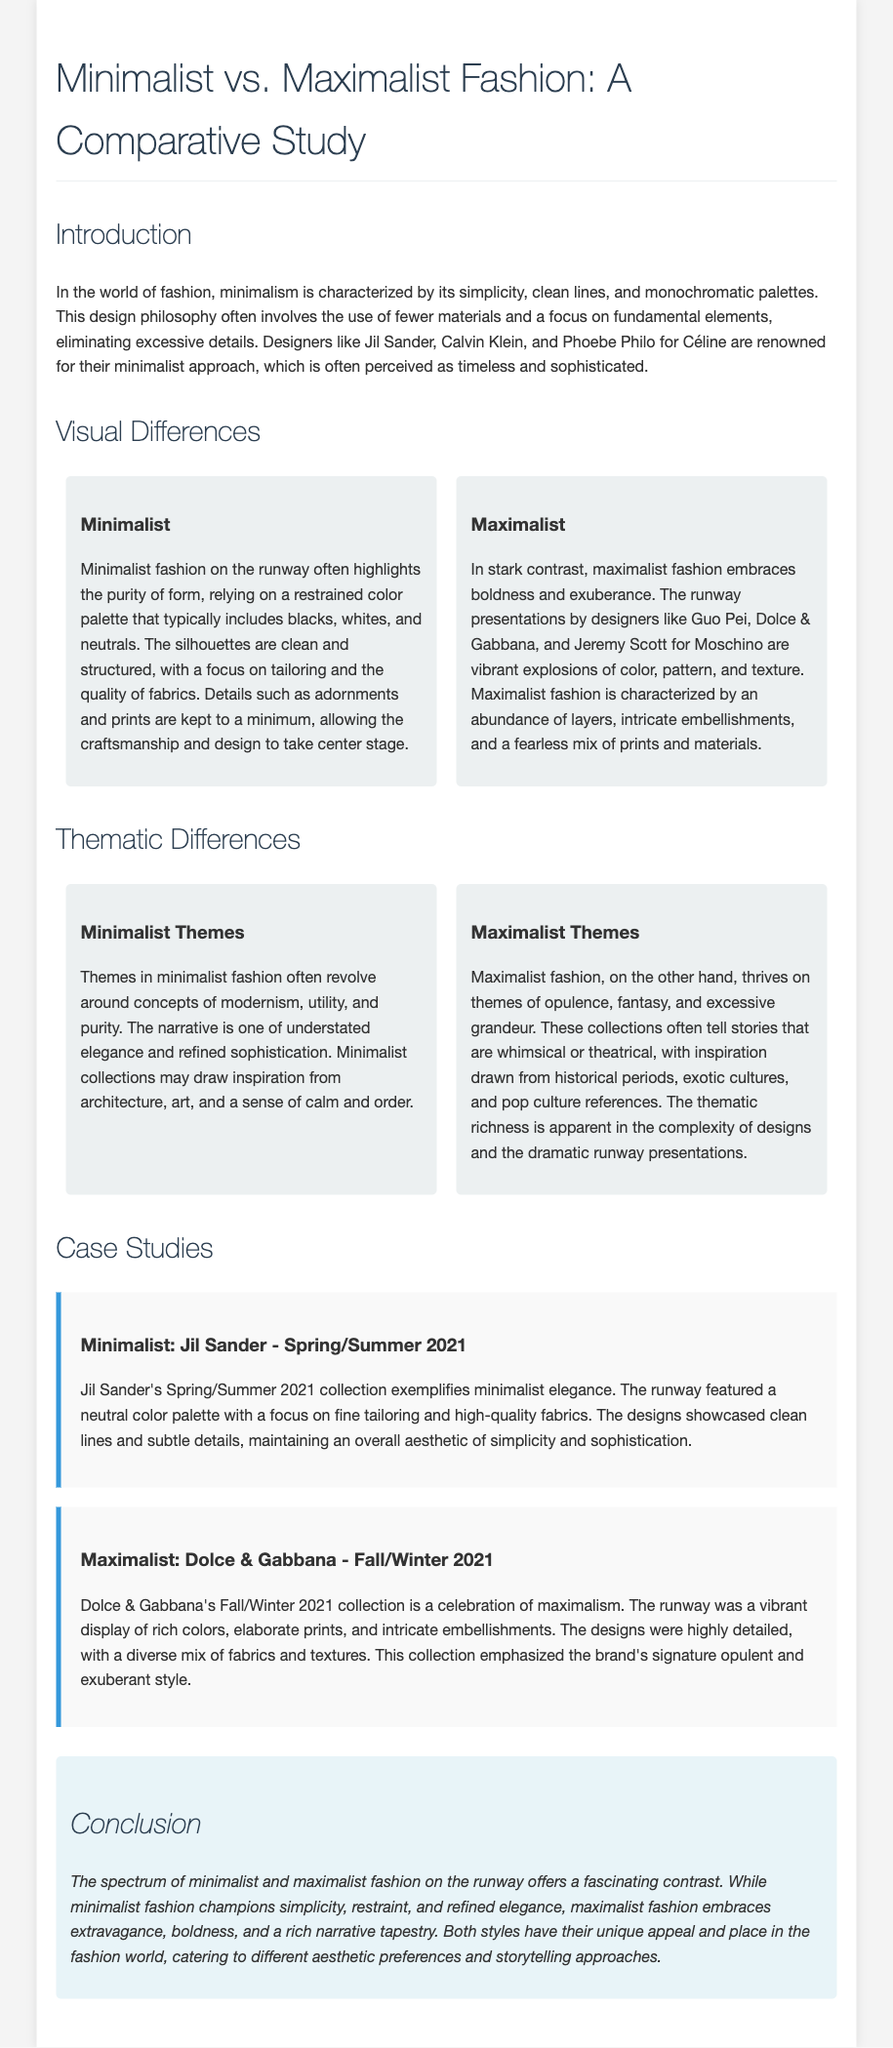What are the names of three renowned minimalist designers? The document lists Jil Sander, Calvin Klein, and Phoebe Philo for Céline as renowned minimalist designers.
Answer: Jil Sander, Calvin Klein, Phoebe Philo What is a key characteristic of minimalist fashion? The document states that minimalist fashion is characterized by simplicity, clean lines, and monochromatic palettes.
Answer: Simplicity Which designers are mentioned as examples of maximalist fashion? The document mentions Guo Pei, Dolce & Gabbana, and Jeremy Scott for Moschino as examples of maximalist fashion.
Answer: Guo Pei, Dolce & Gabbana, Jeremy Scott What color palette does minimalist fashion typically include? The document mentions that the typical color palette for minimalist fashion includes blacks, whites, and neutrals.
Answer: Blacks, whites, neutrals What themes are often found in minimalist fashion? According to the document, themes in minimalist fashion often revolve around modernism, utility, and purity.
Answer: Modernism, utility, purity In which season did Jil Sander present a minimalist collection? The document specifies that Jil Sander's minimalist collection was for Spring/Summer 2021.
Answer: Spring/Summer 2021 What does maximalist fashion thrive on thematically? The document states that maximalist fashion thrives on themes of opulence, fantasy, and excessive grandeur.
Answer: Opulence, fantasy, excessive grandeur Which collection exemplifies maximalism according to the case study? The document indicates that Dolce & Gabbana's Fall/Winter 2021 collection exemplifies maximalism.
Answer: Dolce & Gabbana - Fall/Winter 2021 What is the conclusion about minimalist and maximalist fashion on the runway? The document concludes that minimalist fashion champions simplicity, while maximalist fashion embraces extravagance.
Answer: Minimalism champions simplicity, maximalism embraces extravagance 